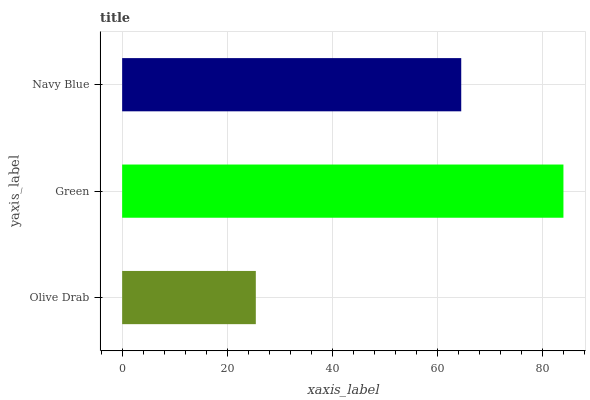Is Olive Drab the minimum?
Answer yes or no. Yes. Is Green the maximum?
Answer yes or no. Yes. Is Navy Blue the minimum?
Answer yes or no. No. Is Navy Blue the maximum?
Answer yes or no. No. Is Green greater than Navy Blue?
Answer yes or no. Yes. Is Navy Blue less than Green?
Answer yes or no. Yes. Is Navy Blue greater than Green?
Answer yes or no. No. Is Green less than Navy Blue?
Answer yes or no. No. Is Navy Blue the high median?
Answer yes or no. Yes. Is Navy Blue the low median?
Answer yes or no. Yes. Is Olive Drab the high median?
Answer yes or no. No. Is Green the low median?
Answer yes or no. No. 